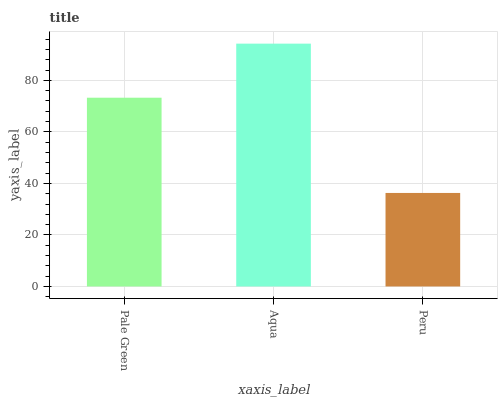Is Peru the minimum?
Answer yes or no. Yes. Is Aqua the maximum?
Answer yes or no. Yes. Is Aqua the minimum?
Answer yes or no. No. Is Peru the maximum?
Answer yes or no. No. Is Aqua greater than Peru?
Answer yes or no. Yes. Is Peru less than Aqua?
Answer yes or no. Yes. Is Peru greater than Aqua?
Answer yes or no. No. Is Aqua less than Peru?
Answer yes or no. No. Is Pale Green the high median?
Answer yes or no. Yes. Is Pale Green the low median?
Answer yes or no. Yes. Is Peru the high median?
Answer yes or no. No. Is Aqua the low median?
Answer yes or no. No. 